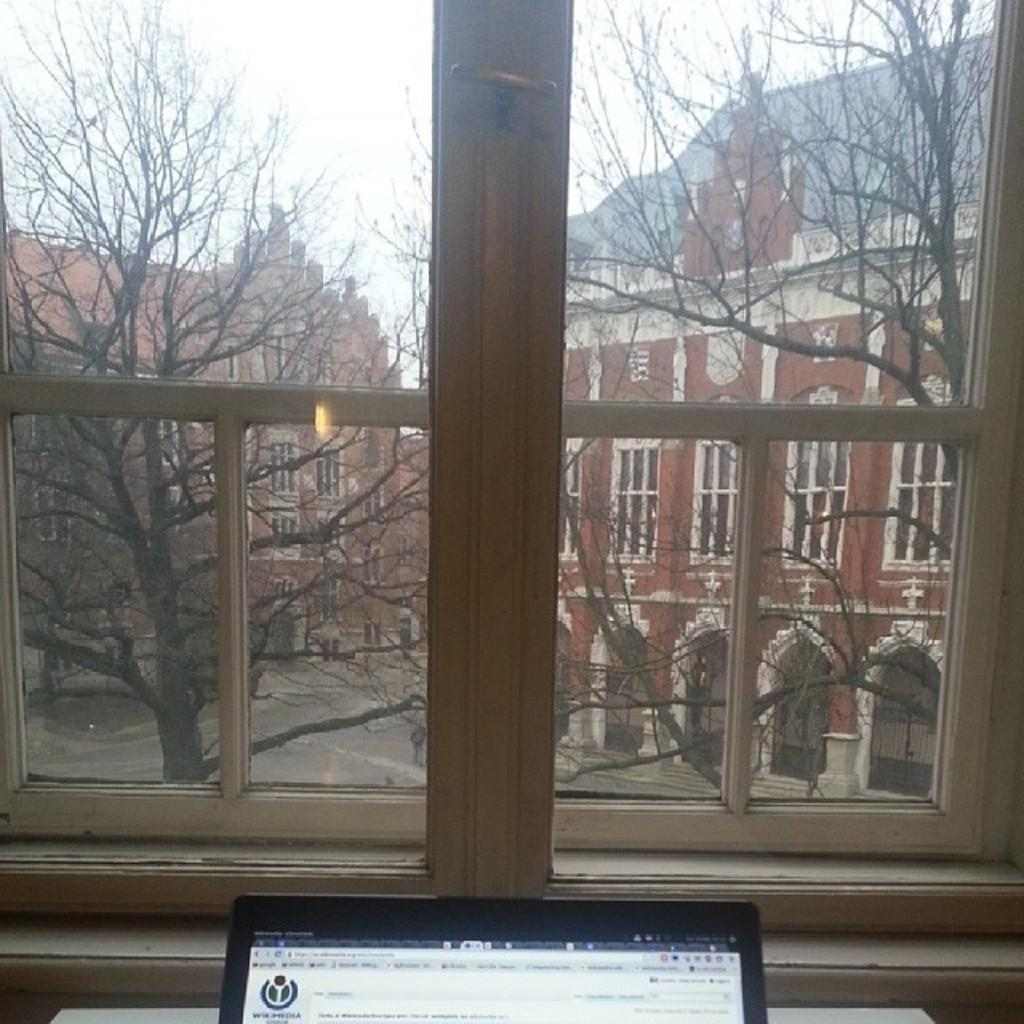What can be seen in the image that allows light to enter a room? There is a window in the image. What is present in the window that may be used to control airflow? A: There is a screen in the image. What type of natural scenery can be seen in the background of the image? There are trees in the background of the image. What type of man-made structures can be seen in the background of the image? There are buildings in the background of the image. What part of the natural environment is visible in the background of the image? The sky is visible in the background of the image. What color is the silver thing hanging from the window in the image? There is no silver thing hanging from the window in the image. How does the brake work on the tree in the background of the image? There is no brake present in the image, and trees do not have brakes. 